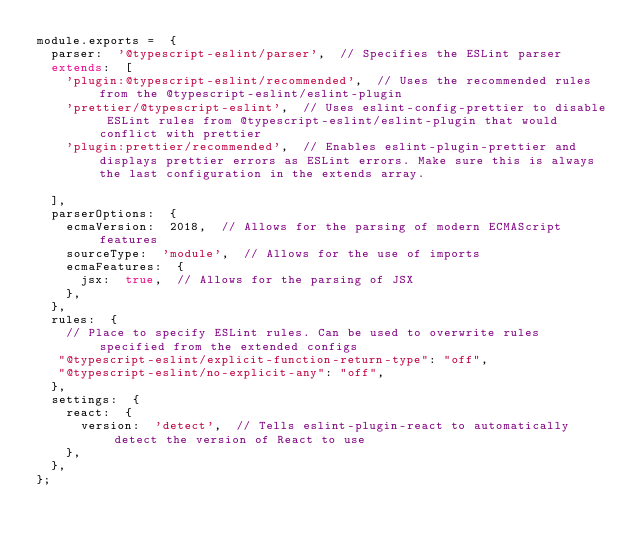Convert code to text. <code><loc_0><loc_0><loc_500><loc_500><_JavaScript_>module.exports =  {
  parser:  '@typescript-eslint/parser',  // Specifies the ESLint parser
  extends:  [
    'plugin:@typescript-eslint/recommended',  // Uses the recommended rules from the @typescript-eslint/eslint-plugin
    'prettier/@typescript-eslint',  // Uses eslint-config-prettier to disable ESLint rules from @typescript-eslint/eslint-plugin that would conflict with prettier
    'plugin:prettier/recommended',  // Enables eslint-plugin-prettier and displays prettier errors as ESLint errors. Make sure this is always the last configuration in the extends array.

  ],
  parserOptions:  {
    ecmaVersion:  2018,  // Allows for the parsing of modern ECMAScript features
    sourceType:  'module',  // Allows for the use of imports
    ecmaFeatures:  {
      jsx:  true,  // Allows for the parsing of JSX
    },
  },
  rules:  {
    // Place to specify ESLint rules. Can be used to overwrite rules specified from the extended configs
   "@typescript-eslint/explicit-function-return-type": "off",
   "@typescript-eslint/no-explicit-any": "off",
  },
  settings:  {
    react:  {
      version:  'detect',  // Tells eslint-plugin-react to automatically detect the version of React to use
    },
  },
};
</code> 